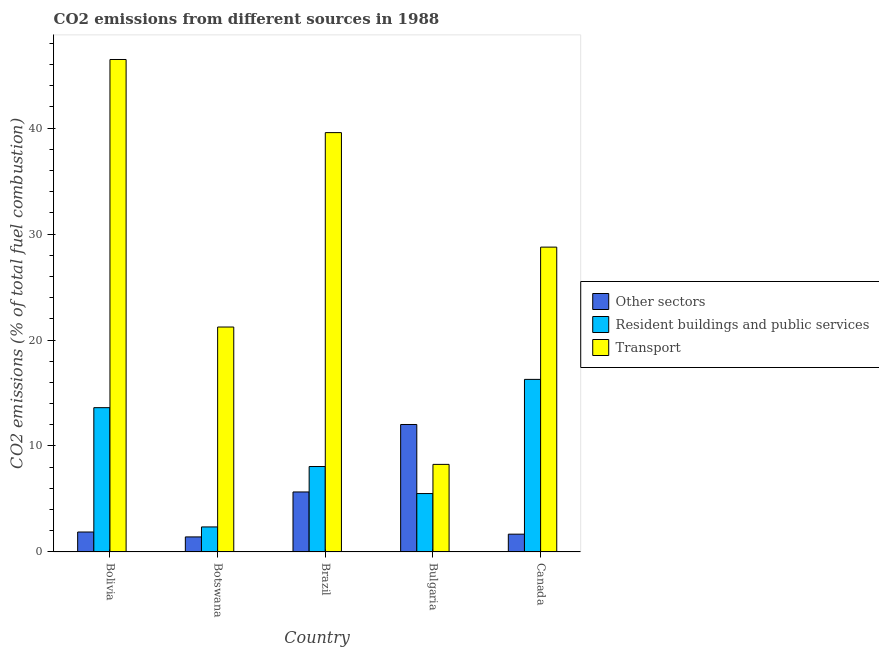How many different coloured bars are there?
Provide a succinct answer. 3. Are the number of bars on each tick of the X-axis equal?
Your answer should be very brief. Yes. How many bars are there on the 2nd tick from the left?
Your response must be concise. 3. What is the label of the 2nd group of bars from the left?
Your response must be concise. Botswana. In how many cases, is the number of bars for a given country not equal to the number of legend labels?
Your answer should be very brief. 0. What is the percentage of co2 emissions from other sectors in Bolivia?
Ensure brevity in your answer.  1.88. Across all countries, what is the maximum percentage of co2 emissions from other sectors?
Keep it short and to the point. 12.03. Across all countries, what is the minimum percentage of co2 emissions from transport?
Your answer should be compact. 8.26. In which country was the percentage of co2 emissions from resident buildings and public services minimum?
Your answer should be very brief. Botswana. What is the total percentage of co2 emissions from other sectors in the graph?
Offer a terse response. 22.65. What is the difference between the percentage of co2 emissions from other sectors in Brazil and that in Bulgaria?
Keep it short and to the point. -6.37. What is the difference between the percentage of co2 emissions from other sectors in Bulgaria and the percentage of co2 emissions from resident buildings and public services in Canada?
Your answer should be very brief. -4.26. What is the average percentage of co2 emissions from transport per country?
Your answer should be very brief. 28.86. What is the difference between the percentage of co2 emissions from transport and percentage of co2 emissions from other sectors in Brazil?
Make the answer very short. 33.92. In how many countries, is the percentage of co2 emissions from transport greater than 44 %?
Your answer should be compact. 1. What is the ratio of the percentage of co2 emissions from other sectors in Bolivia to that in Botswana?
Provide a short and direct response. 1.33. Is the percentage of co2 emissions from other sectors in Botswana less than that in Bulgaria?
Keep it short and to the point. Yes. What is the difference between the highest and the second highest percentage of co2 emissions from transport?
Your response must be concise. 6.9. What is the difference between the highest and the lowest percentage of co2 emissions from transport?
Ensure brevity in your answer.  38.22. In how many countries, is the percentage of co2 emissions from other sectors greater than the average percentage of co2 emissions from other sectors taken over all countries?
Offer a very short reply. 2. Is the sum of the percentage of co2 emissions from other sectors in Brazil and Bulgaria greater than the maximum percentage of co2 emissions from transport across all countries?
Your answer should be compact. No. What does the 3rd bar from the left in Bolivia represents?
Your answer should be very brief. Transport. What does the 3rd bar from the right in Bolivia represents?
Your answer should be very brief. Other sectors. Is it the case that in every country, the sum of the percentage of co2 emissions from other sectors and percentage of co2 emissions from resident buildings and public services is greater than the percentage of co2 emissions from transport?
Ensure brevity in your answer.  No. How many countries are there in the graph?
Offer a very short reply. 5. Does the graph contain any zero values?
Your answer should be compact. No. Where does the legend appear in the graph?
Make the answer very short. Center right. How many legend labels are there?
Offer a very short reply. 3. How are the legend labels stacked?
Provide a succinct answer. Vertical. What is the title of the graph?
Your response must be concise. CO2 emissions from different sources in 1988. What is the label or title of the Y-axis?
Provide a short and direct response. CO2 emissions (% of total fuel combustion). What is the CO2 emissions (% of total fuel combustion) of Other sectors in Bolivia?
Your answer should be compact. 1.88. What is the CO2 emissions (% of total fuel combustion) of Resident buildings and public services in Bolivia?
Keep it short and to the point. 13.62. What is the CO2 emissions (% of total fuel combustion) of Transport in Bolivia?
Provide a short and direct response. 46.48. What is the CO2 emissions (% of total fuel combustion) in Other sectors in Botswana?
Keep it short and to the point. 1.42. What is the CO2 emissions (% of total fuel combustion) in Resident buildings and public services in Botswana?
Offer a terse response. 2.36. What is the CO2 emissions (% of total fuel combustion) in Transport in Botswana?
Offer a terse response. 21.23. What is the CO2 emissions (% of total fuel combustion) of Other sectors in Brazil?
Make the answer very short. 5.66. What is the CO2 emissions (% of total fuel combustion) of Resident buildings and public services in Brazil?
Provide a short and direct response. 8.06. What is the CO2 emissions (% of total fuel combustion) in Transport in Brazil?
Make the answer very short. 39.58. What is the CO2 emissions (% of total fuel combustion) of Other sectors in Bulgaria?
Offer a terse response. 12.03. What is the CO2 emissions (% of total fuel combustion) of Resident buildings and public services in Bulgaria?
Keep it short and to the point. 5.51. What is the CO2 emissions (% of total fuel combustion) in Transport in Bulgaria?
Make the answer very short. 8.26. What is the CO2 emissions (% of total fuel combustion) of Other sectors in Canada?
Ensure brevity in your answer.  1.67. What is the CO2 emissions (% of total fuel combustion) in Resident buildings and public services in Canada?
Offer a very short reply. 16.28. What is the CO2 emissions (% of total fuel combustion) in Transport in Canada?
Give a very brief answer. 28.77. Across all countries, what is the maximum CO2 emissions (% of total fuel combustion) of Other sectors?
Your answer should be compact. 12.03. Across all countries, what is the maximum CO2 emissions (% of total fuel combustion) in Resident buildings and public services?
Ensure brevity in your answer.  16.28. Across all countries, what is the maximum CO2 emissions (% of total fuel combustion) in Transport?
Provide a short and direct response. 46.48. Across all countries, what is the minimum CO2 emissions (% of total fuel combustion) of Other sectors?
Provide a short and direct response. 1.42. Across all countries, what is the minimum CO2 emissions (% of total fuel combustion) in Resident buildings and public services?
Give a very brief answer. 2.36. Across all countries, what is the minimum CO2 emissions (% of total fuel combustion) in Transport?
Make the answer very short. 8.26. What is the total CO2 emissions (% of total fuel combustion) in Other sectors in the graph?
Keep it short and to the point. 22.65. What is the total CO2 emissions (% of total fuel combustion) of Resident buildings and public services in the graph?
Your response must be concise. 45.82. What is the total CO2 emissions (% of total fuel combustion) in Transport in the graph?
Make the answer very short. 144.31. What is the difference between the CO2 emissions (% of total fuel combustion) of Other sectors in Bolivia and that in Botswana?
Provide a succinct answer. 0.46. What is the difference between the CO2 emissions (% of total fuel combustion) in Resident buildings and public services in Bolivia and that in Botswana?
Your response must be concise. 11.26. What is the difference between the CO2 emissions (% of total fuel combustion) in Transport in Bolivia and that in Botswana?
Keep it short and to the point. 25.25. What is the difference between the CO2 emissions (% of total fuel combustion) in Other sectors in Bolivia and that in Brazil?
Your response must be concise. -3.78. What is the difference between the CO2 emissions (% of total fuel combustion) of Resident buildings and public services in Bolivia and that in Brazil?
Ensure brevity in your answer.  5.56. What is the difference between the CO2 emissions (% of total fuel combustion) of Transport in Bolivia and that in Brazil?
Your response must be concise. 6.9. What is the difference between the CO2 emissions (% of total fuel combustion) of Other sectors in Bolivia and that in Bulgaria?
Provide a short and direct response. -10.15. What is the difference between the CO2 emissions (% of total fuel combustion) of Resident buildings and public services in Bolivia and that in Bulgaria?
Ensure brevity in your answer.  8.11. What is the difference between the CO2 emissions (% of total fuel combustion) of Transport in Bolivia and that in Bulgaria?
Your answer should be very brief. 38.22. What is the difference between the CO2 emissions (% of total fuel combustion) in Other sectors in Bolivia and that in Canada?
Keep it short and to the point. 0.2. What is the difference between the CO2 emissions (% of total fuel combustion) of Resident buildings and public services in Bolivia and that in Canada?
Provide a short and direct response. -2.67. What is the difference between the CO2 emissions (% of total fuel combustion) in Transport in Bolivia and that in Canada?
Your answer should be very brief. 17.71. What is the difference between the CO2 emissions (% of total fuel combustion) in Other sectors in Botswana and that in Brazil?
Offer a terse response. -4.24. What is the difference between the CO2 emissions (% of total fuel combustion) of Resident buildings and public services in Botswana and that in Brazil?
Provide a succinct answer. -5.7. What is the difference between the CO2 emissions (% of total fuel combustion) in Transport in Botswana and that in Brazil?
Your answer should be very brief. -18.35. What is the difference between the CO2 emissions (% of total fuel combustion) in Other sectors in Botswana and that in Bulgaria?
Offer a terse response. -10.61. What is the difference between the CO2 emissions (% of total fuel combustion) in Resident buildings and public services in Botswana and that in Bulgaria?
Make the answer very short. -3.15. What is the difference between the CO2 emissions (% of total fuel combustion) in Transport in Botswana and that in Bulgaria?
Your response must be concise. 12.97. What is the difference between the CO2 emissions (% of total fuel combustion) of Other sectors in Botswana and that in Canada?
Give a very brief answer. -0.26. What is the difference between the CO2 emissions (% of total fuel combustion) in Resident buildings and public services in Botswana and that in Canada?
Provide a short and direct response. -13.93. What is the difference between the CO2 emissions (% of total fuel combustion) of Transport in Botswana and that in Canada?
Keep it short and to the point. -7.54. What is the difference between the CO2 emissions (% of total fuel combustion) of Other sectors in Brazil and that in Bulgaria?
Offer a very short reply. -6.37. What is the difference between the CO2 emissions (% of total fuel combustion) in Resident buildings and public services in Brazil and that in Bulgaria?
Provide a short and direct response. 2.55. What is the difference between the CO2 emissions (% of total fuel combustion) in Transport in Brazil and that in Bulgaria?
Make the answer very short. 31.32. What is the difference between the CO2 emissions (% of total fuel combustion) in Other sectors in Brazil and that in Canada?
Keep it short and to the point. 3.98. What is the difference between the CO2 emissions (% of total fuel combustion) in Resident buildings and public services in Brazil and that in Canada?
Provide a short and direct response. -8.23. What is the difference between the CO2 emissions (% of total fuel combustion) of Transport in Brazil and that in Canada?
Keep it short and to the point. 10.81. What is the difference between the CO2 emissions (% of total fuel combustion) of Other sectors in Bulgaria and that in Canada?
Ensure brevity in your answer.  10.35. What is the difference between the CO2 emissions (% of total fuel combustion) of Resident buildings and public services in Bulgaria and that in Canada?
Provide a short and direct response. -10.78. What is the difference between the CO2 emissions (% of total fuel combustion) of Transport in Bulgaria and that in Canada?
Offer a very short reply. -20.51. What is the difference between the CO2 emissions (% of total fuel combustion) in Other sectors in Bolivia and the CO2 emissions (% of total fuel combustion) in Resident buildings and public services in Botswana?
Offer a terse response. -0.48. What is the difference between the CO2 emissions (% of total fuel combustion) in Other sectors in Bolivia and the CO2 emissions (% of total fuel combustion) in Transport in Botswana?
Provide a succinct answer. -19.35. What is the difference between the CO2 emissions (% of total fuel combustion) in Resident buildings and public services in Bolivia and the CO2 emissions (% of total fuel combustion) in Transport in Botswana?
Your answer should be very brief. -7.61. What is the difference between the CO2 emissions (% of total fuel combustion) in Other sectors in Bolivia and the CO2 emissions (% of total fuel combustion) in Resident buildings and public services in Brazil?
Offer a terse response. -6.18. What is the difference between the CO2 emissions (% of total fuel combustion) of Other sectors in Bolivia and the CO2 emissions (% of total fuel combustion) of Transport in Brazil?
Your response must be concise. -37.7. What is the difference between the CO2 emissions (% of total fuel combustion) in Resident buildings and public services in Bolivia and the CO2 emissions (% of total fuel combustion) in Transport in Brazil?
Your answer should be compact. -25.96. What is the difference between the CO2 emissions (% of total fuel combustion) in Other sectors in Bolivia and the CO2 emissions (% of total fuel combustion) in Resident buildings and public services in Bulgaria?
Your answer should be compact. -3.63. What is the difference between the CO2 emissions (% of total fuel combustion) of Other sectors in Bolivia and the CO2 emissions (% of total fuel combustion) of Transport in Bulgaria?
Give a very brief answer. -6.38. What is the difference between the CO2 emissions (% of total fuel combustion) in Resident buildings and public services in Bolivia and the CO2 emissions (% of total fuel combustion) in Transport in Bulgaria?
Provide a succinct answer. 5.35. What is the difference between the CO2 emissions (% of total fuel combustion) of Other sectors in Bolivia and the CO2 emissions (% of total fuel combustion) of Resident buildings and public services in Canada?
Offer a terse response. -14.41. What is the difference between the CO2 emissions (% of total fuel combustion) in Other sectors in Bolivia and the CO2 emissions (% of total fuel combustion) in Transport in Canada?
Offer a very short reply. -26.89. What is the difference between the CO2 emissions (% of total fuel combustion) in Resident buildings and public services in Bolivia and the CO2 emissions (% of total fuel combustion) in Transport in Canada?
Provide a short and direct response. -15.15. What is the difference between the CO2 emissions (% of total fuel combustion) of Other sectors in Botswana and the CO2 emissions (% of total fuel combustion) of Resident buildings and public services in Brazil?
Provide a succinct answer. -6.64. What is the difference between the CO2 emissions (% of total fuel combustion) in Other sectors in Botswana and the CO2 emissions (% of total fuel combustion) in Transport in Brazil?
Provide a short and direct response. -38.16. What is the difference between the CO2 emissions (% of total fuel combustion) of Resident buildings and public services in Botswana and the CO2 emissions (% of total fuel combustion) of Transport in Brazil?
Keep it short and to the point. -37.22. What is the difference between the CO2 emissions (% of total fuel combustion) of Other sectors in Botswana and the CO2 emissions (% of total fuel combustion) of Resident buildings and public services in Bulgaria?
Your answer should be very brief. -4.09. What is the difference between the CO2 emissions (% of total fuel combustion) in Other sectors in Botswana and the CO2 emissions (% of total fuel combustion) in Transport in Bulgaria?
Your response must be concise. -6.85. What is the difference between the CO2 emissions (% of total fuel combustion) in Resident buildings and public services in Botswana and the CO2 emissions (% of total fuel combustion) in Transport in Bulgaria?
Provide a short and direct response. -5.9. What is the difference between the CO2 emissions (% of total fuel combustion) in Other sectors in Botswana and the CO2 emissions (% of total fuel combustion) in Resident buildings and public services in Canada?
Your answer should be compact. -14.87. What is the difference between the CO2 emissions (% of total fuel combustion) of Other sectors in Botswana and the CO2 emissions (% of total fuel combustion) of Transport in Canada?
Provide a short and direct response. -27.35. What is the difference between the CO2 emissions (% of total fuel combustion) in Resident buildings and public services in Botswana and the CO2 emissions (% of total fuel combustion) in Transport in Canada?
Offer a terse response. -26.41. What is the difference between the CO2 emissions (% of total fuel combustion) of Other sectors in Brazil and the CO2 emissions (% of total fuel combustion) of Resident buildings and public services in Bulgaria?
Make the answer very short. 0.15. What is the difference between the CO2 emissions (% of total fuel combustion) of Other sectors in Brazil and the CO2 emissions (% of total fuel combustion) of Transport in Bulgaria?
Your answer should be very brief. -2.6. What is the difference between the CO2 emissions (% of total fuel combustion) in Resident buildings and public services in Brazil and the CO2 emissions (% of total fuel combustion) in Transport in Bulgaria?
Make the answer very short. -0.2. What is the difference between the CO2 emissions (% of total fuel combustion) in Other sectors in Brazil and the CO2 emissions (% of total fuel combustion) in Resident buildings and public services in Canada?
Your response must be concise. -10.63. What is the difference between the CO2 emissions (% of total fuel combustion) in Other sectors in Brazil and the CO2 emissions (% of total fuel combustion) in Transport in Canada?
Your answer should be very brief. -23.11. What is the difference between the CO2 emissions (% of total fuel combustion) of Resident buildings and public services in Brazil and the CO2 emissions (% of total fuel combustion) of Transport in Canada?
Your answer should be very brief. -20.71. What is the difference between the CO2 emissions (% of total fuel combustion) of Other sectors in Bulgaria and the CO2 emissions (% of total fuel combustion) of Resident buildings and public services in Canada?
Keep it short and to the point. -4.26. What is the difference between the CO2 emissions (% of total fuel combustion) in Other sectors in Bulgaria and the CO2 emissions (% of total fuel combustion) in Transport in Canada?
Provide a succinct answer. -16.74. What is the difference between the CO2 emissions (% of total fuel combustion) in Resident buildings and public services in Bulgaria and the CO2 emissions (% of total fuel combustion) in Transport in Canada?
Keep it short and to the point. -23.26. What is the average CO2 emissions (% of total fuel combustion) of Other sectors per country?
Your response must be concise. 4.53. What is the average CO2 emissions (% of total fuel combustion) of Resident buildings and public services per country?
Keep it short and to the point. 9.16. What is the average CO2 emissions (% of total fuel combustion) in Transport per country?
Your answer should be compact. 28.86. What is the difference between the CO2 emissions (% of total fuel combustion) of Other sectors and CO2 emissions (% of total fuel combustion) of Resident buildings and public services in Bolivia?
Provide a succinct answer. -11.74. What is the difference between the CO2 emissions (% of total fuel combustion) in Other sectors and CO2 emissions (% of total fuel combustion) in Transport in Bolivia?
Make the answer very short. -44.6. What is the difference between the CO2 emissions (% of total fuel combustion) in Resident buildings and public services and CO2 emissions (% of total fuel combustion) in Transport in Bolivia?
Make the answer very short. -32.86. What is the difference between the CO2 emissions (% of total fuel combustion) in Other sectors and CO2 emissions (% of total fuel combustion) in Resident buildings and public services in Botswana?
Your answer should be compact. -0.94. What is the difference between the CO2 emissions (% of total fuel combustion) in Other sectors and CO2 emissions (% of total fuel combustion) in Transport in Botswana?
Your response must be concise. -19.81. What is the difference between the CO2 emissions (% of total fuel combustion) of Resident buildings and public services and CO2 emissions (% of total fuel combustion) of Transport in Botswana?
Provide a succinct answer. -18.87. What is the difference between the CO2 emissions (% of total fuel combustion) of Other sectors and CO2 emissions (% of total fuel combustion) of Resident buildings and public services in Brazil?
Offer a terse response. -2.4. What is the difference between the CO2 emissions (% of total fuel combustion) in Other sectors and CO2 emissions (% of total fuel combustion) in Transport in Brazil?
Offer a terse response. -33.92. What is the difference between the CO2 emissions (% of total fuel combustion) in Resident buildings and public services and CO2 emissions (% of total fuel combustion) in Transport in Brazil?
Your answer should be very brief. -31.52. What is the difference between the CO2 emissions (% of total fuel combustion) of Other sectors and CO2 emissions (% of total fuel combustion) of Resident buildings and public services in Bulgaria?
Ensure brevity in your answer.  6.52. What is the difference between the CO2 emissions (% of total fuel combustion) in Other sectors and CO2 emissions (% of total fuel combustion) in Transport in Bulgaria?
Make the answer very short. 3.77. What is the difference between the CO2 emissions (% of total fuel combustion) in Resident buildings and public services and CO2 emissions (% of total fuel combustion) in Transport in Bulgaria?
Your answer should be compact. -2.75. What is the difference between the CO2 emissions (% of total fuel combustion) in Other sectors and CO2 emissions (% of total fuel combustion) in Resident buildings and public services in Canada?
Provide a succinct answer. -14.61. What is the difference between the CO2 emissions (% of total fuel combustion) in Other sectors and CO2 emissions (% of total fuel combustion) in Transport in Canada?
Ensure brevity in your answer.  -27.1. What is the difference between the CO2 emissions (% of total fuel combustion) of Resident buildings and public services and CO2 emissions (% of total fuel combustion) of Transport in Canada?
Provide a succinct answer. -12.49. What is the ratio of the CO2 emissions (% of total fuel combustion) of Other sectors in Bolivia to that in Botswana?
Make the answer very short. 1.33. What is the ratio of the CO2 emissions (% of total fuel combustion) of Resident buildings and public services in Bolivia to that in Botswana?
Your answer should be very brief. 5.77. What is the ratio of the CO2 emissions (% of total fuel combustion) in Transport in Bolivia to that in Botswana?
Offer a terse response. 2.19. What is the ratio of the CO2 emissions (% of total fuel combustion) in Other sectors in Bolivia to that in Brazil?
Ensure brevity in your answer.  0.33. What is the ratio of the CO2 emissions (% of total fuel combustion) of Resident buildings and public services in Bolivia to that in Brazil?
Give a very brief answer. 1.69. What is the ratio of the CO2 emissions (% of total fuel combustion) of Transport in Bolivia to that in Brazil?
Provide a short and direct response. 1.17. What is the ratio of the CO2 emissions (% of total fuel combustion) of Other sectors in Bolivia to that in Bulgaria?
Offer a very short reply. 0.16. What is the ratio of the CO2 emissions (% of total fuel combustion) of Resident buildings and public services in Bolivia to that in Bulgaria?
Make the answer very short. 2.47. What is the ratio of the CO2 emissions (% of total fuel combustion) of Transport in Bolivia to that in Bulgaria?
Keep it short and to the point. 5.63. What is the ratio of the CO2 emissions (% of total fuel combustion) in Other sectors in Bolivia to that in Canada?
Offer a terse response. 1.12. What is the ratio of the CO2 emissions (% of total fuel combustion) of Resident buildings and public services in Bolivia to that in Canada?
Offer a very short reply. 0.84. What is the ratio of the CO2 emissions (% of total fuel combustion) in Transport in Bolivia to that in Canada?
Keep it short and to the point. 1.62. What is the ratio of the CO2 emissions (% of total fuel combustion) of Other sectors in Botswana to that in Brazil?
Offer a terse response. 0.25. What is the ratio of the CO2 emissions (% of total fuel combustion) in Resident buildings and public services in Botswana to that in Brazil?
Offer a terse response. 0.29. What is the ratio of the CO2 emissions (% of total fuel combustion) in Transport in Botswana to that in Brazil?
Make the answer very short. 0.54. What is the ratio of the CO2 emissions (% of total fuel combustion) in Other sectors in Botswana to that in Bulgaria?
Provide a succinct answer. 0.12. What is the ratio of the CO2 emissions (% of total fuel combustion) in Resident buildings and public services in Botswana to that in Bulgaria?
Offer a very short reply. 0.43. What is the ratio of the CO2 emissions (% of total fuel combustion) in Transport in Botswana to that in Bulgaria?
Keep it short and to the point. 2.57. What is the ratio of the CO2 emissions (% of total fuel combustion) of Other sectors in Botswana to that in Canada?
Provide a short and direct response. 0.85. What is the ratio of the CO2 emissions (% of total fuel combustion) in Resident buildings and public services in Botswana to that in Canada?
Your answer should be very brief. 0.14. What is the ratio of the CO2 emissions (% of total fuel combustion) in Transport in Botswana to that in Canada?
Provide a succinct answer. 0.74. What is the ratio of the CO2 emissions (% of total fuel combustion) in Other sectors in Brazil to that in Bulgaria?
Your answer should be very brief. 0.47. What is the ratio of the CO2 emissions (% of total fuel combustion) in Resident buildings and public services in Brazil to that in Bulgaria?
Provide a short and direct response. 1.46. What is the ratio of the CO2 emissions (% of total fuel combustion) in Transport in Brazil to that in Bulgaria?
Keep it short and to the point. 4.79. What is the ratio of the CO2 emissions (% of total fuel combustion) in Other sectors in Brazil to that in Canada?
Provide a short and direct response. 3.38. What is the ratio of the CO2 emissions (% of total fuel combustion) in Resident buildings and public services in Brazil to that in Canada?
Make the answer very short. 0.49. What is the ratio of the CO2 emissions (% of total fuel combustion) of Transport in Brazil to that in Canada?
Provide a succinct answer. 1.38. What is the ratio of the CO2 emissions (% of total fuel combustion) of Other sectors in Bulgaria to that in Canada?
Provide a short and direct response. 7.18. What is the ratio of the CO2 emissions (% of total fuel combustion) in Resident buildings and public services in Bulgaria to that in Canada?
Make the answer very short. 0.34. What is the ratio of the CO2 emissions (% of total fuel combustion) in Transport in Bulgaria to that in Canada?
Offer a very short reply. 0.29. What is the difference between the highest and the second highest CO2 emissions (% of total fuel combustion) of Other sectors?
Provide a short and direct response. 6.37. What is the difference between the highest and the second highest CO2 emissions (% of total fuel combustion) in Resident buildings and public services?
Your answer should be very brief. 2.67. What is the difference between the highest and the second highest CO2 emissions (% of total fuel combustion) in Transport?
Offer a very short reply. 6.9. What is the difference between the highest and the lowest CO2 emissions (% of total fuel combustion) of Other sectors?
Ensure brevity in your answer.  10.61. What is the difference between the highest and the lowest CO2 emissions (% of total fuel combustion) in Resident buildings and public services?
Offer a very short reply. 13.93. What is the difference between the highest and the lowest CO2 emissions (% of total fuel combustion) of Transport?
Provide a succinct answer. 38.22. 